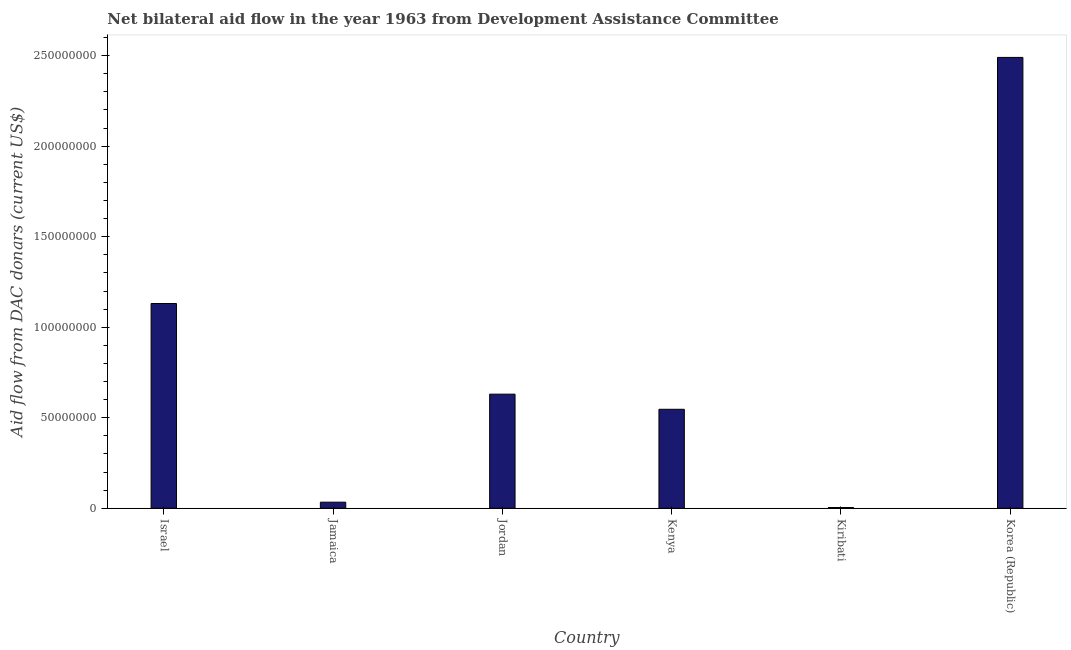Does the graph contain any zero values?
Your answer should be compact. No. What is the title of the graph?
Keep it short and to the point. Net bilateral aid flow in the year 1963 from Development Assistance Committee. What is the label or title of the X-axis?
Provide a short and direct response. Country. What is the label or title of the Y-axis?
Give a very brief answer. Aid flow from DAC donars (current US$). What is the net bilateral aid flows from dac donors in Kiribati?
Your answer should be compact. 4.10e+05. Across all countries, what is the maximum net bilateral aid flows from dac donors?
Keep it short and to the point. 2.49e+08. In which country was the net bilateral aid flows from dac donors minimum?
Give a very brief answer. Kiribati. What is the sum of the net bilateral aid flows from dac donors?
Ensure brevity in your answer.  4.84e+08. What is the difference between the net bilateral aid flows from dac donors in Jamaica and Jordan?
Provide a short and direct response. -5.97e+07. What is the average net bilateral aid flows from dac donors per country?
Your answer should be very brief. 8.06e+07. What is the median net bilateral aid flows from dac donors?
Your answer should be very brief. 5.88e+07. What is the ratio of the net bilateral aid flows from dac donors in Israel to that in Kiribati?
Give a very brief answer. 275.83. Is the difference between the net bilateral aid flows from dac donors in Jamaica and Kenya greater than the difference between any two countries?
Your answer should be very brief. No. What is the difference between the highest and the second highest net bilateral aid flows from dac donors?
Give a very brief answer. 1.36e+08. Is the sum of the net bilateral aid flows from dac donors in Kenya and Kiribati greater than the maximum net bilateral aid flows from dac donors across all countries?
Offer a terse response. No. What is the difference between the highest and the lowest net bilateral aid flows from dac donors?
Your answer should be very brief. 2.49e+08. In how many countries, is the net bilateral aid flows from dac donors greater than the average net bilateral aid flows from dac donors taken over all countries?
Your answer should be compact. 2. How many countries are there in the graph?
Your response must be concise. 6. What is the difference between two consecutive major ticks on the Y-axis?
Your answer should be very brief. 5.00e+07. What is the Aid flow from DAC donars (current US$) in Israel?
Provide a succinct answer. 1.13e+08. What is the Aid flow from DAC donars (current US$) of Jamaica?
Your answer should be very brief. 3.36e+06. What is the Aid flow from DAC donars (current US$) of Jordan?
Offer a terse response. 6.30e+07. What is the Aid flow from DAC donars (current US$) in Kenya?
Make the answer very short. 5.47e+07. What is the Aid flow from DAC donars (current US$) in Korea (Republic)?
Your answer should be compact. 2.49e+08. What is the difference between the Aid flow from DAC donars (current US$) in Israel and Jamaica?
Your response must be concise. 1.10e+08. What is the difference between the Aid flow from DAC donars (current US$) in Israel and Jordan?
Give a very brief answer. 5.01e+07. What is the difference between the Aid flow from DAC donars (current US$) in Israel and Kenya?
Provide a succinct answer. 5.84e+07. What is the difference between the Aid flow from DAC donars (current US$) in Israel and Kiribati?
Give a very brief answer. 1.13e+08. What is the difference between the Aid flow from DAC donars (current US$) in Israel and Korea (Republic)?
Your response must be concise. -1.36e+08. What is the difference between the Aid flow from DAC donars (current US$) in Jamaica and Jordan?
Offer a terse response. -5.97e+07. What is the difference between the Aid flow from DAC donars (current US$) in Jamaica and Kenya?
Your answer should be very brief. -5.13e+07. What is the difference between the Aid flow from DAC donars (current US$) in Jamaica and Kiribati?
Give a very brief answer. 2.95e+06. What is the difference between the Aid flow from DAC donars (current US$) in Jamaica and Korea (Republic)?
Your answer should be compact. -2.46e+08. What is the difference between the Aid flow from DAC donars (current US$) in Jordan and Kenya?
Ensure brevity in your answer.  8.35e+06. What is the difference between the Aid flow from DAC donars (current US$) in Jordan and Kiribati?
Provide a succinct answer. 6.26e+07. What is the difference between the Aid flow from DAC donars (current US$) in Jordan and Korea (Republic)?
Your answer should be compact. -1.86e+08. What is the difference between the Aid flow from DAC donars (current US$) in Kenya and Kiribati?
Offer a terse response. 5.43e+07. What is the difference between the Aid flow from DAC donars (current US$) in Kenya and Korea (Republic)?
Keep it short and to the point. -1.94e+08. What is the difference between the Aid flow from DAC donars (current US$) in Kiribati and Korea (Republic)?
Ensure brevity in your answer.  -2.49e+08. What is the ratio of the Aid flow from DAC donars (current US$) in Israel to that in Jamaica?
Your answer should be compact. 33.66. What is the ratio of the Aid flow from DAC donars (current US$) in Israel to that in Jordan?
Keep it short and to the point. 1.79. What is the ratio of the Aid flow from DAC donars (current US$) in Israel to that in Kenya?
Provide a short and direct response. 2.07. What is the ratio of the Aid flow from DAC donars (current US$) in Israel to that in Kiribati?
Ensure brevity in your answer.  275.83. What is the ratio of the Aid flow from DAC donars (current US$) in Israel to that in Korea (Republic)?
Provide a short and direct response. 0.45. What is the ratio of the Aid flow from DAC donars (current US$) in Jamaica to that in Jordan?
Ensure brevity in your answer.  0.05. What is the ratio of the Aid flow from DAC donars (current US$) in Jamaica to that in Kenya?
Offer a very short reply. 0.06. What is the ratio of the Aid flow from DAC donars (current US$) in Jamaica to that in Kiribati?
Provide a short and direct response. 8.2. What is the ratio of the Aid flow from DAC donars (current US$) in Jamaica to that in Korea (Republic)?
Offer a terse response. 0.01. What is the ratio of the Aid flow from DAC donars (current US$) in Jordan to that in Kenya?
Provide a short and direct response. 1.15. What is the ratio of the Aid flow from DAC donars (current US$) in Jordan to that in Kiribati?
Your answer should be compact. 153.71. What is the ratio of the Aid flow from DAC donars (current US$) in Jordan to that in Korea (Republic)?
Keep it short and to the point. 0.25. What is the ratio of the Aid flow from DAC donars (current US$) in Kenya to that in Kiribati?
Keep it short and to the point. 133.34. What is the ratio of the Aid flow from DAC donars (current US$) in Kenya to that in Korea (Republic)?
Your response must be concise. 0.22. What is the ratio of the Aid flow from DAC donars (current US$) in Kiribati to that in Korea (Republic)?
Ensure brevity in your answer.  0. 